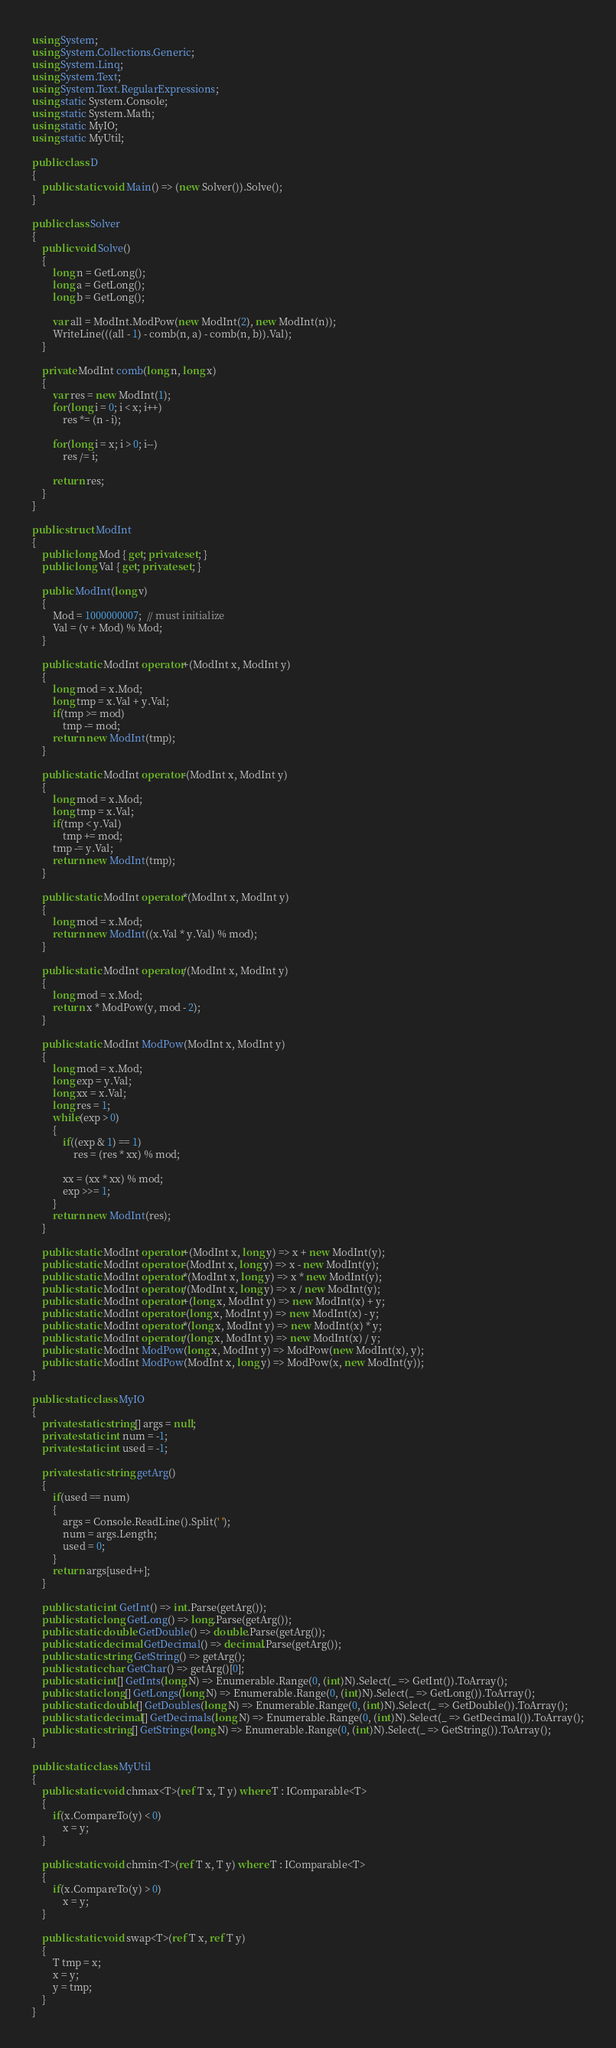<code> <loc_0><loc_0><loc_500><loc_500><_C#_>using System;
using System.Collections.Generic;
using System.Linq;
using System.Text;
using System.Text.RegularExpressions;
using static System.Console;
using static System.Math;
using static MyIO;
using static MyUtil;

public class D
{
	public static void Main() => (new Solver()).Solve();
}

public class Solver
{
	public void Solve()
	{
		long n = GetLong();
		long a = GetLong();
		long b = GetLong();

		var all = ModInt.ModPow(new ModInt(2), new ModInt(n));
		WriteLine(((all - 1) - comb(n, a) - comb(n, b)).Val);
	}

	private ModInt comb(long n, long x)
	{
		var res = new ModInt(1);
		for(long i = 0; i < x; i++)
			res *= (n - i);

		for(long i = x; i > 0; i--)
			res /= i;

		return res;
	}
}

public struct ModInt
{
	public long Mod { get; private set; }
	public long Val { get; private set; }

	public ModInt(long v)
	{
		Mod = 1000000007;  // must initialize
		Val = (v + Mod) % Mod;
	}

	public static ModInt operator+(ModInt x, ModInt y)
	{
		long mod = x.Mod;
		long tmp = x.Val + y.Val;
		if(tmp >= mod)
			tmp -= mod;
		return new ModInt(tmp);
	}

	public static ModInt operator-(ModInt x, ModInt y)
	{
		long mod = x.Mod;
		long tmp = x.Val;
		if(tmp < y.Val)
			tmp += mod;
		tmp -= y.Val;
		return new ModInt(tmp);
	}

	public static ModInt operator*(ModInt x, ModInt y)
	{
		long mod = x.Mod;
		return new ModInt((x.Val * y.Val) % mod);
	}

	public static ModInt operator/(ModInt x, ModInt y)
	{
		long mod = x.Mod;
		return x * ModPow(y, mod - 2);
	}

	public static ModInt ModPow(ModInt x, ModInt y)
	{
		long mod = x.Mod;
		long exp = y.Val;
		long xx = x.Val;
		long res = 1;
		while(exp > 0)
		{
			if((exp & 1) == 1)
				res = (res * xx) % mod;

			xx = (xx * xx) % mod;
			exp >>= 1;
		}
		return new ModInt(res);
	}

	public static ModInt operator+(ModInt x, long y) => x + new ModInt(y);
	public static ModInt operator-(ModInt x, long y) => x - new ModInt(y);
	public static ModInt operator*(ModInt x, long y) => x * new ModInt(y);
	public static ModInt operator/(ModInt x, long y) => x / new ModInt(y);
	public static ModInt operator+(long x, ModInt y) => new ModInt(x) + y;
	public static ModInt operator-(long x, ModInt y) => new ModInt(x) - y;
	public static ModInt operator*(long x, ModInt y) => new ModInt(x) * y;
	public static ModInt operator/(long x, ModInt y) => new ModInt(x) / y;
	public static ModInt ModPow(long x, ModInt y) => ModPow(new ModInt(x), y);
	public static ModInt ModPow(ModInt x, long y) => ModPow(x, new ModInt(y));
}

public static class MyIO
{
	private static string[] args = null;
	private static int num = -1;
	private static int used = -1;

	private static string getArg()
	{
		if(used == num)
		{
			args = Console.ReadLine().Split(' ');
			num = args.Length;
			used = 0;
		}
		return args[used++];
	}

	public static int GetInt() => int.Parse(getArg());
	public static long GetLong() => long.Parse(getArg());
	public static double GetDouble() => double.Parse(getArg());
	public static decimal GetDecimal() => decimal.Parse(getArg());
	public static string GetString() => getArg();
	public static char GetChar() => getArg()[0];
	public static int[] GetInts(long N) => Enumerable.Range(0, (int)N).Select(_ => GetInt()).ToArray();
	public static long[] GetLongs(long N) => Enumerable.Range(0, (int)N).Select(_ => GetLong()).ToArray();
	public static double[] GetDoubles(long N) => Enumerable.Range(0, (int)N).Select(_ => GetDouble()).ToArray();
	public static decimal[] GetDecimals(long N) => Enumerable.Range(0, (int)N).Select(_ => GetDecimal()).ToArray();
	public static string[] GetStrings(long N) => Enumerable.Range(0, (int)N).Select(_ => GetString()).ToArray();
}

public static class MyUtil
{
	public static void chmax<T>(ref T x, T y) where T : IComparable<T>
	{
		if(x.CompareTo(y) < 0)
			x = y;
	}

	public static void chmin<T>(ref T x, T y) where T : IComparable<T>
	{
		if(x.CompareTo(y) > 0)
			x = y;
	}

	public static void swap<T>(ref T x, ref T y)
	{
		T tmp = x;
		x = y;
		y = tmp;
	}
}</code> 